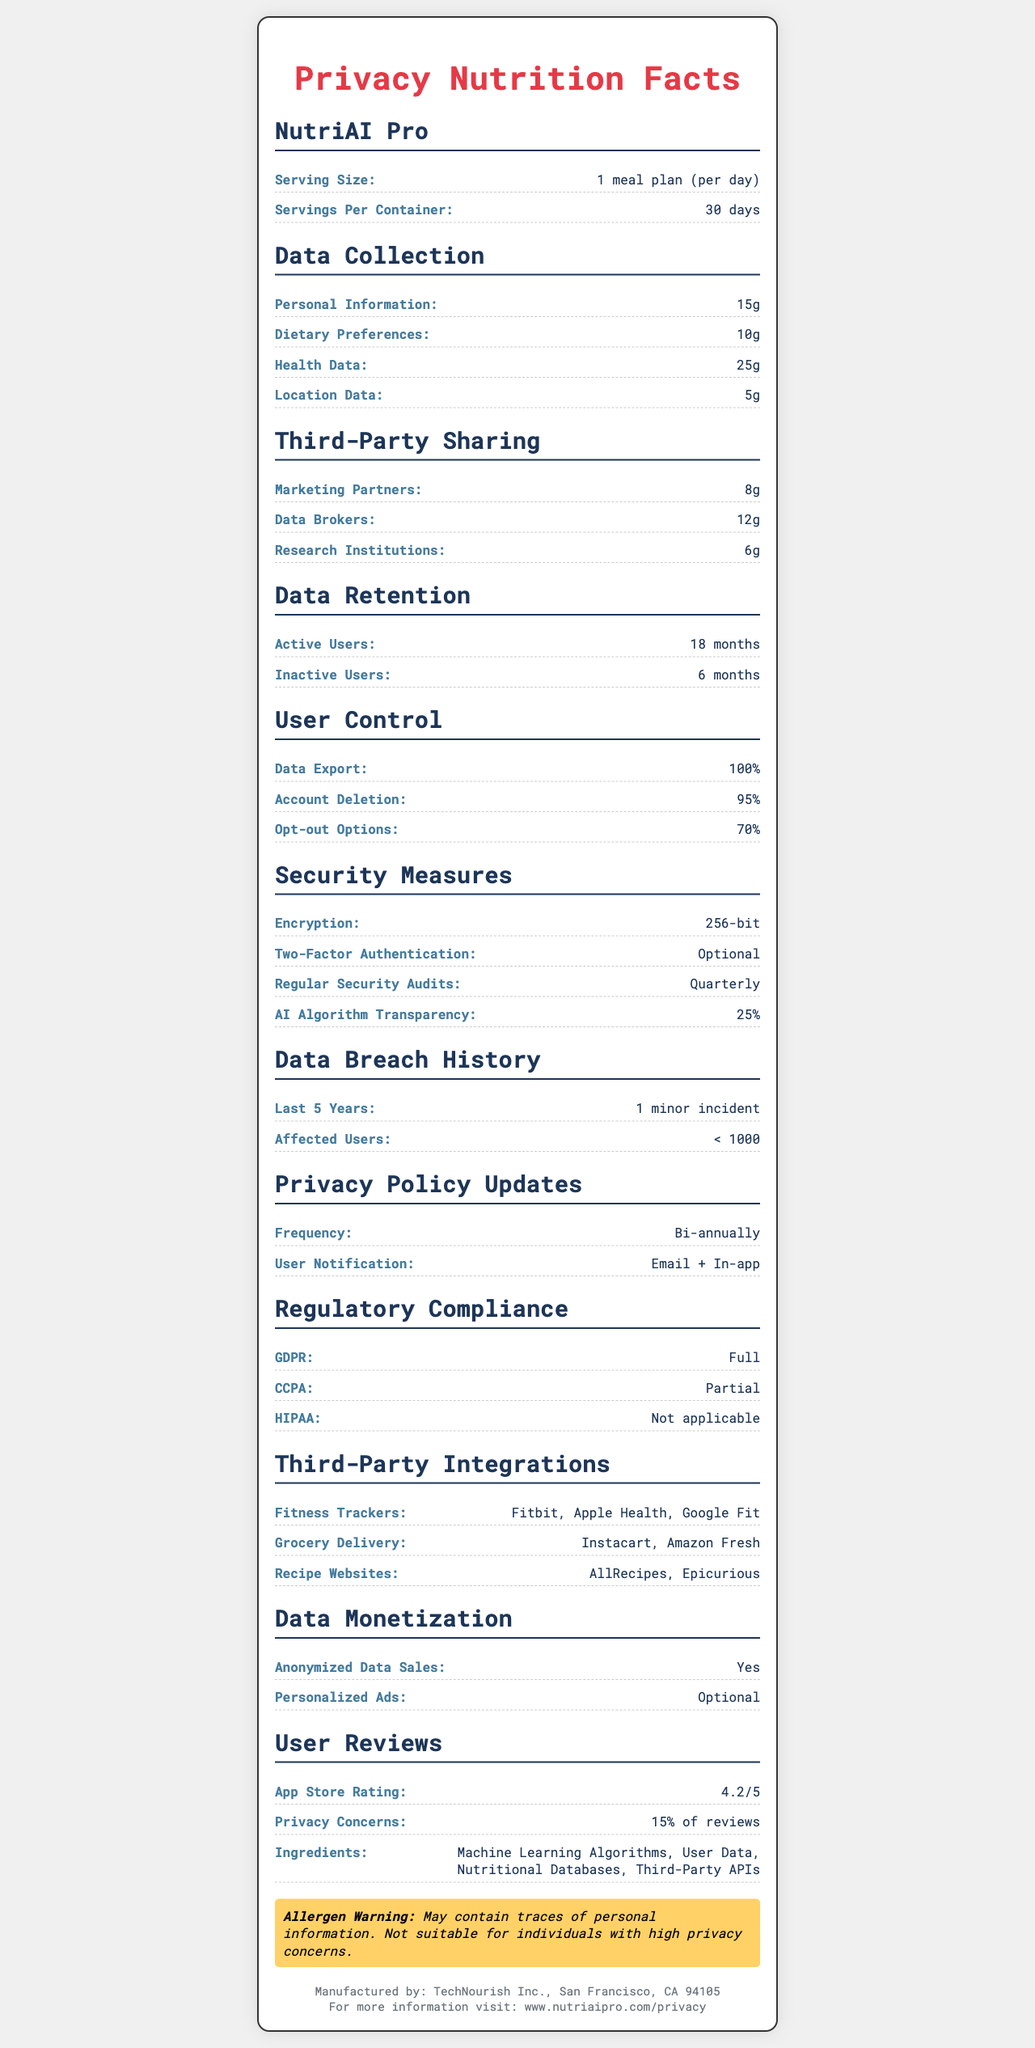what is the serving size for NutriAI Pro? The document states that the serving size is one meal plan for each day.
Answer: 1 meal plan (per day) How long is the data retention period for inactive users? The document mentions that data for inactive users is retained for 6 months.
Answer: 6 months What percentage of user control is provided for data export? According to the document, users have 100% control over data export.
Answer: 100% How often are privacy policy updates provided? The document states that privacy policy updates occur bi-annually.
Answer: Bi-annually What level of AI algorithm transparency is provided by NutriAI Pro? The document shows that NutriAI Pro provides 25% transparency for its AI algorithms.
Answer: 25% Who are some of the third-party integrations listed? A. Fitbit B. Apple Health C. Google Fit D. All of the above The document lists Fitbit, Apple Health, and Google Fit as examples of third-party integrations.
Answer: D What is the encryption level used by NutriAI Pro? A. 128-bit B. 192-bit C. 256-bit D. 512-bit The document states that NutriAI Pro uses 256-bit encryption.
Answer: C Can users delete their accounts completely? While the document mentions that account deletion is 95% effective, it implies that accounts cannot be completely deleted.
Answer: No Is NutriAI Pro fully compliant with HIPAA regulations? The document clearly states that NutriAI Pro is not applicable under HIPAA regulations.
Answer: No What is the major allergen warning provided? The document specifies that NutriAI Pro may contain traces of personal information and that it is not suitable for individuals with high privacy concerns.
Answer: May contain traces of personal information. Not suitable for individuals with high privacy concerns. How many data retention periods are there for different user states? The document lists two retention periods: 18 months for active users and 6 months for inactive users.
Answer: Two Summarize the key privacy-related points of the NutriAI Pro Privacy Nutrition Facts document. The NutriAI Pro Privacy Nutrition Facts document provides a comprehensive overview of the application's data collection, sharing, retention, user control, and security measures. Key highlights include data collection types, third-party sharing, user control options, encryption levels, privacy policy update frequencies, regulatory compliance details, and user reviews with privacy concerns.
Answer: NutriAI Pro collects personal information, dietary preferences, health data, and location data. It shares data with marketing partners, data brokers, and research institutions. Data retention periods are 18 months for active users and 6 months for inactive users. Users have significant control over data export (100%) and account deletion (95%). Security measures include 256-bit encryption, optional two-factor authentication, and quarterly security audits. The AI algorithm transparency is 25%. NutriAI Pro has had one minor data breach affecting fewer than 1000 users in the last five years. Privacy policy updates occur bi-annually, and it complies fully with GDPR but partially with CCPA. Integrations include fitness trackers, grocery delivery, and recipe websites. The app also monetizes data through anonymized data sales and optional personalized ads. User reviews are generally positive with a 4.2/5 rating, but 15% report privacy concerns. How many security breaches has NutriAI Pro experienced in the last five years? The document indicates that there has been 1 minor data incident in the last five years affecting fewer than 1000 users.
Answer: 1 minor incident What is the average calorie count per meal in NutriAI Pro's meal plans? The document states that calorie counts vary based on the plan, but does not provide an average calorie count per meal plan.
Answer: Not enough information 